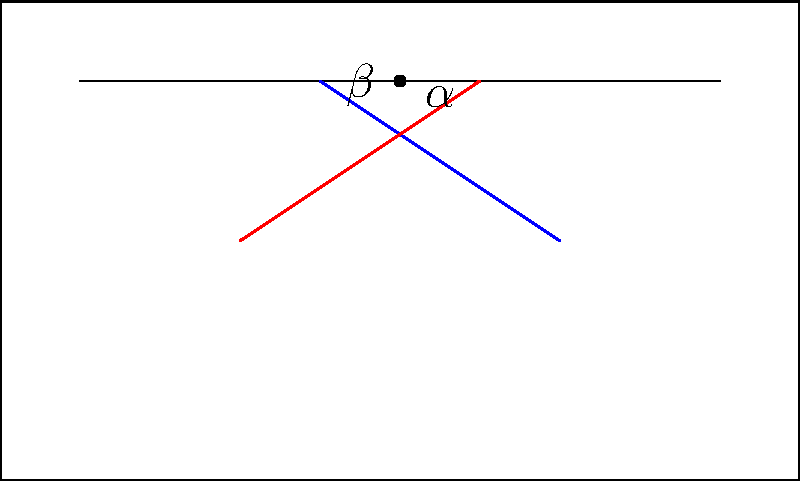As a supportive parent teaching your teenager about driving, you want to explain the importance of windshield wipers. You decide to use this as an opportunity to incorporate a math lesson. Looking at the simplified front view of a car, the windshield wipers form two angles, $\alpha$ and $\beta$. If the wipers are symmetrical and $\alpha = 40°$, what is the value of $\alpha + \beta$? Let's approach this step-by-step:

1) First, we need to understand what symmetrical means in this context. Symmetrical wipers will form equal angles on either side of their meeting point.

2) We're given that $\alpha = 40°$. Due to symmetry, $\beta$ must also be 40°.

3) The question asks for the sum of $\alpha$ and $\beta$.

4) So, we simply need to add these angles:

   $\alpha + \beta = 40° + 40° = 80°$

5) This result makes sense geometrically as well. The wipers are attached at the bottom of the windshield and sweep up to form these angles. The total angle they sweep should be less than 180° (a straight line) for practical functionality.

Remember, understanding these geometric principles can help in appreciating the design and functionality of car components, which is valuable knowledge for a new driver.
Answer: $80°$ 